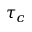<formula> <loc_0><loc_0><loc_500><loc_500>\tau _ { c }</formula> 